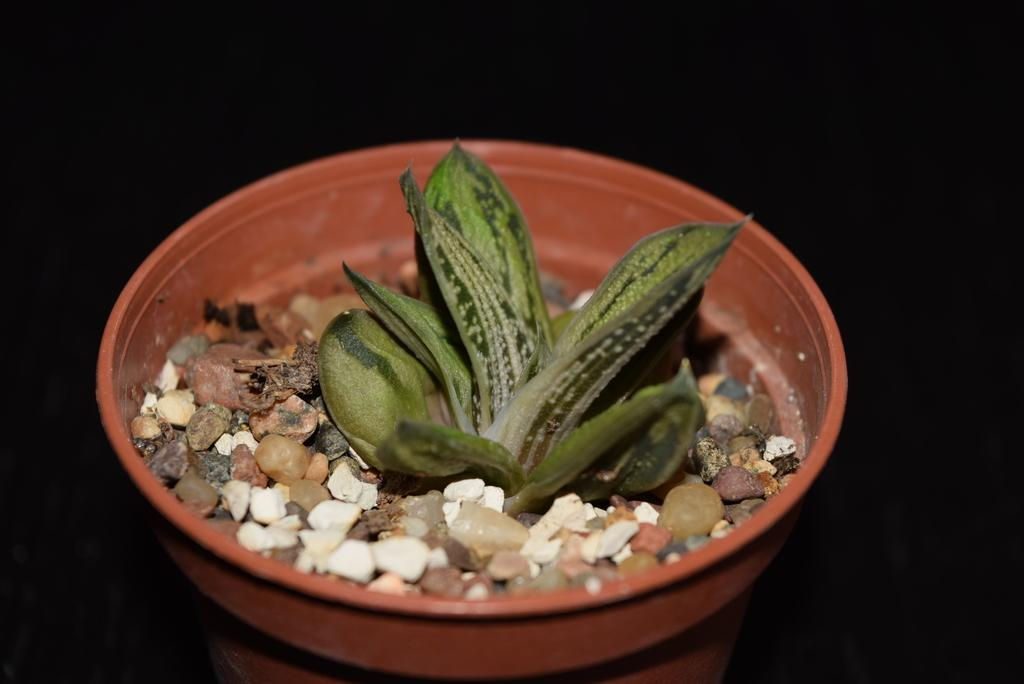What object is the main focus of the image? There is a pot in the image. What is inside the pot? The pot contains small stones. Is there anything else in the pot besides the stones? Yes, there is a plant in the pot. What type of salt can be seen on the plant in the image? There is no salt present in the image; it features a pot with small stones and a plant. How many rabbits are visible in the image? There are no rabbits present in the image. 